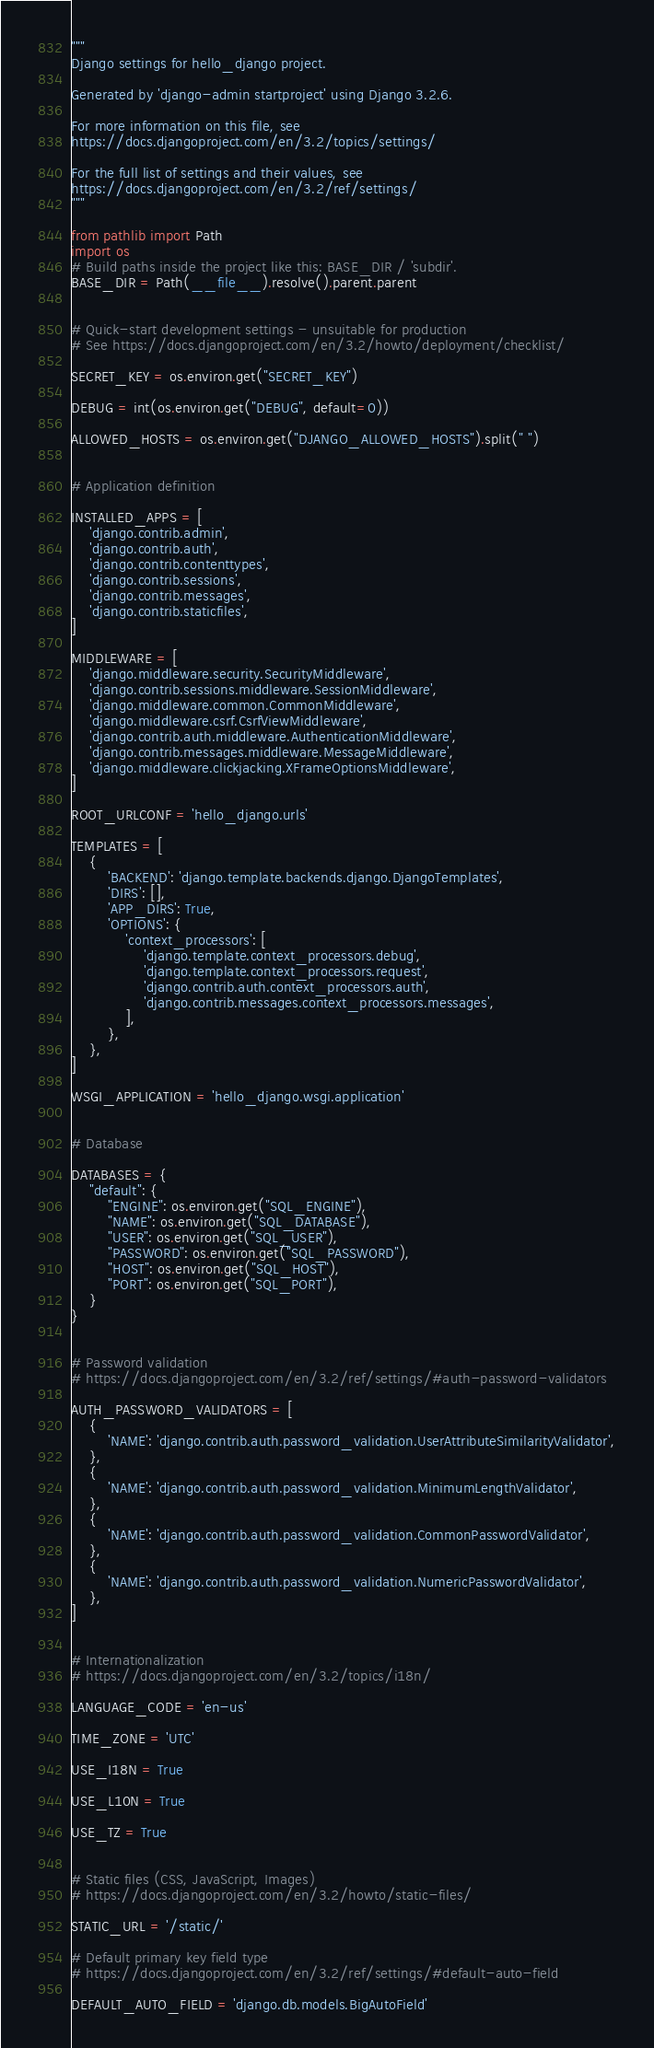<code> <loc_0><loc_0><loc_500><loc_500><_Python_>"""
Django settings for hello_django project.

Generated by 'django-admin startproject' using Django 3.2.6.

For more information on this file, see
https://docs.djangoproject.com/en/3.2/topics/settings/

For the full list of settings and their values, see
https://docs.djangoproject.com/en/3.2/ref/settings/
"""

from pathlib import Path
import os
# Build paths inside the project like this: BASE_DIR / 'subdir'.
BASE_DIR = Path(__file__).resolve().parent.parent


# Quick-start development settings - unsuitable for production
# See https://docs.djangoproject.com/en/3.2/howto/deployment/checklist/

SECRET_KEY = os.environ.get("SECRET_KEY")

DEBUG = int(os.environ.get("DEBUG", default=0))

ALLOWED_HOSTS = os.environ.get("DJANGO_ALLOWED_HOSTS").split(" ")


# Application definition

INSTALLED_APPS = [
    'django.contrib.admin',
    'django.contrib.auth',
    'django.contrib.contenttypes',
    'django.contrib.sessions',
    'django.contrib.messages',
    'django.contrib.staticfiles',
]

MIDDLEWARE = [
    'django.middleware.security.SecurityMiddleware',
    'django.contrib.sessions.middleware.SessionMiddleware',
    'django.middleware.common.CommonMiddleware',
    'django.middleware.csrf.CsrfViewMiddleware',
    'django.contrib.auth.middleware.AuthenticationMiddleware',
    'django.contrib.messages.middleware.MessageMiddleware',
    'django.middleware.clickjacking.XFrameOptionsMiddleware',
]

ROOT_URLCONF = 'hello_django.urls'

TEMPLATES = [
    {
        'BACKEND': 'django.template.backends.django.DjangoTemplates',
        'DIRS': [],
        'APP_DIRS': True,
        'OPTIONS': {
            'context_processors': [
                'django.template.context_processors.debug',
                'django.template.context_processors.request',
                'django.contrib.auth.context_processors.auth',
                'django.contrib.messages.context_processors.messages',
            ],
        },
    },
]

WSGI_APPLICATION = 'hello_django.wsgi.application'


# Database

DATABASES = {
    "default": {
        "ENGINE": os.environ.get("SQL_ENGINE"),
        "NAME": os.environ.get("SQL_DATABASE"),
        "USER": os.environ.get("SQL_USER"),
        "PASSWORD": os.environ.get("SQL_PASSWORD"),
        "HOST": os.environ.get("SQL_HOST"),
        "PORT": os.environ.get("SQL_PORT"),
    }
}


# Password validation
# https://docs.djangoproject.com/en/3.2/ref/settings/#auth-password-validators

AUTH_PASSWORD_VALIDATORS = [
    {
        'NAME': 'django.contrib.auth.password_validation.UserAttributeSimilarityValidator',
    },
    {
        'NAME': 'django.contrib.auth.password_validation.MinimumLengthValidator',
    },
    {
        'NAME': 'django.contrib.auth.password_validation.CommonPasswordValidator',
    },
    {
        'NAME': 'django.contrib.auth.password_validation.NumericPasswordValidator',
    },
]


# Internationalization
# https://docs.djangoproject.com/en/3.2/topics/i18n/

LANGUAGE_CODE = 'en-us'

TIME_ZONE = 'UTC'

USE_I18N = True

USE_L10N = True

USE_TZ = True


# Static files (CSS, JavaScript, Images)
# https://docs.djangoproject.com/en/3.2/howto/static-files/

STATIC_URL = '/static/'

# Default primary key field type
# https://docs.djangoproject.com/en/3.2/ref/settings/#default-auto-field

DEFAULT_AUTO_FIELD = 'django.db.models.BigAutoField'
</code> 